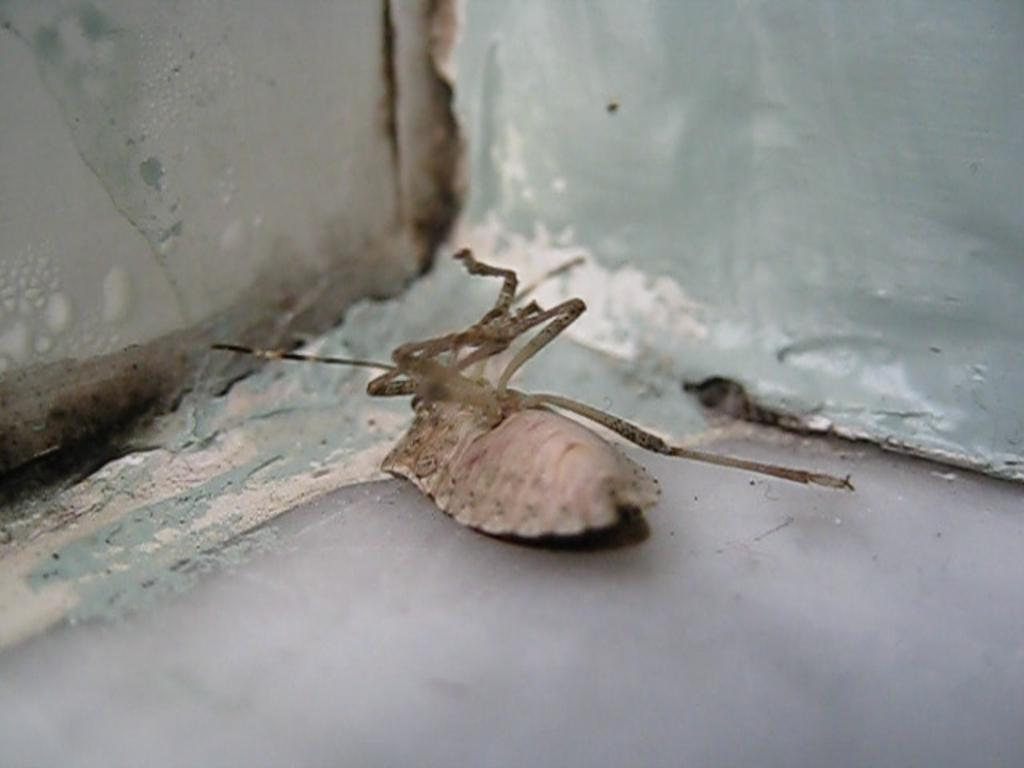What type of creature can be seen in the image? There is an insect in the image. Where is the insect located? The insect is on the floor. What can be seen in the background of the image? There is a wall visible at the top of the image. What type of cherry is the insect holding in its claws in the image? There is no cherry present in the image, and insects do not have claws to hold objects. 